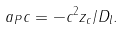<formula> <loc_0><loc_0><loc_500><loc_500>a _ { P } c = - c ^ { 2 } z _ { c } / D _ { l } .</formula> 